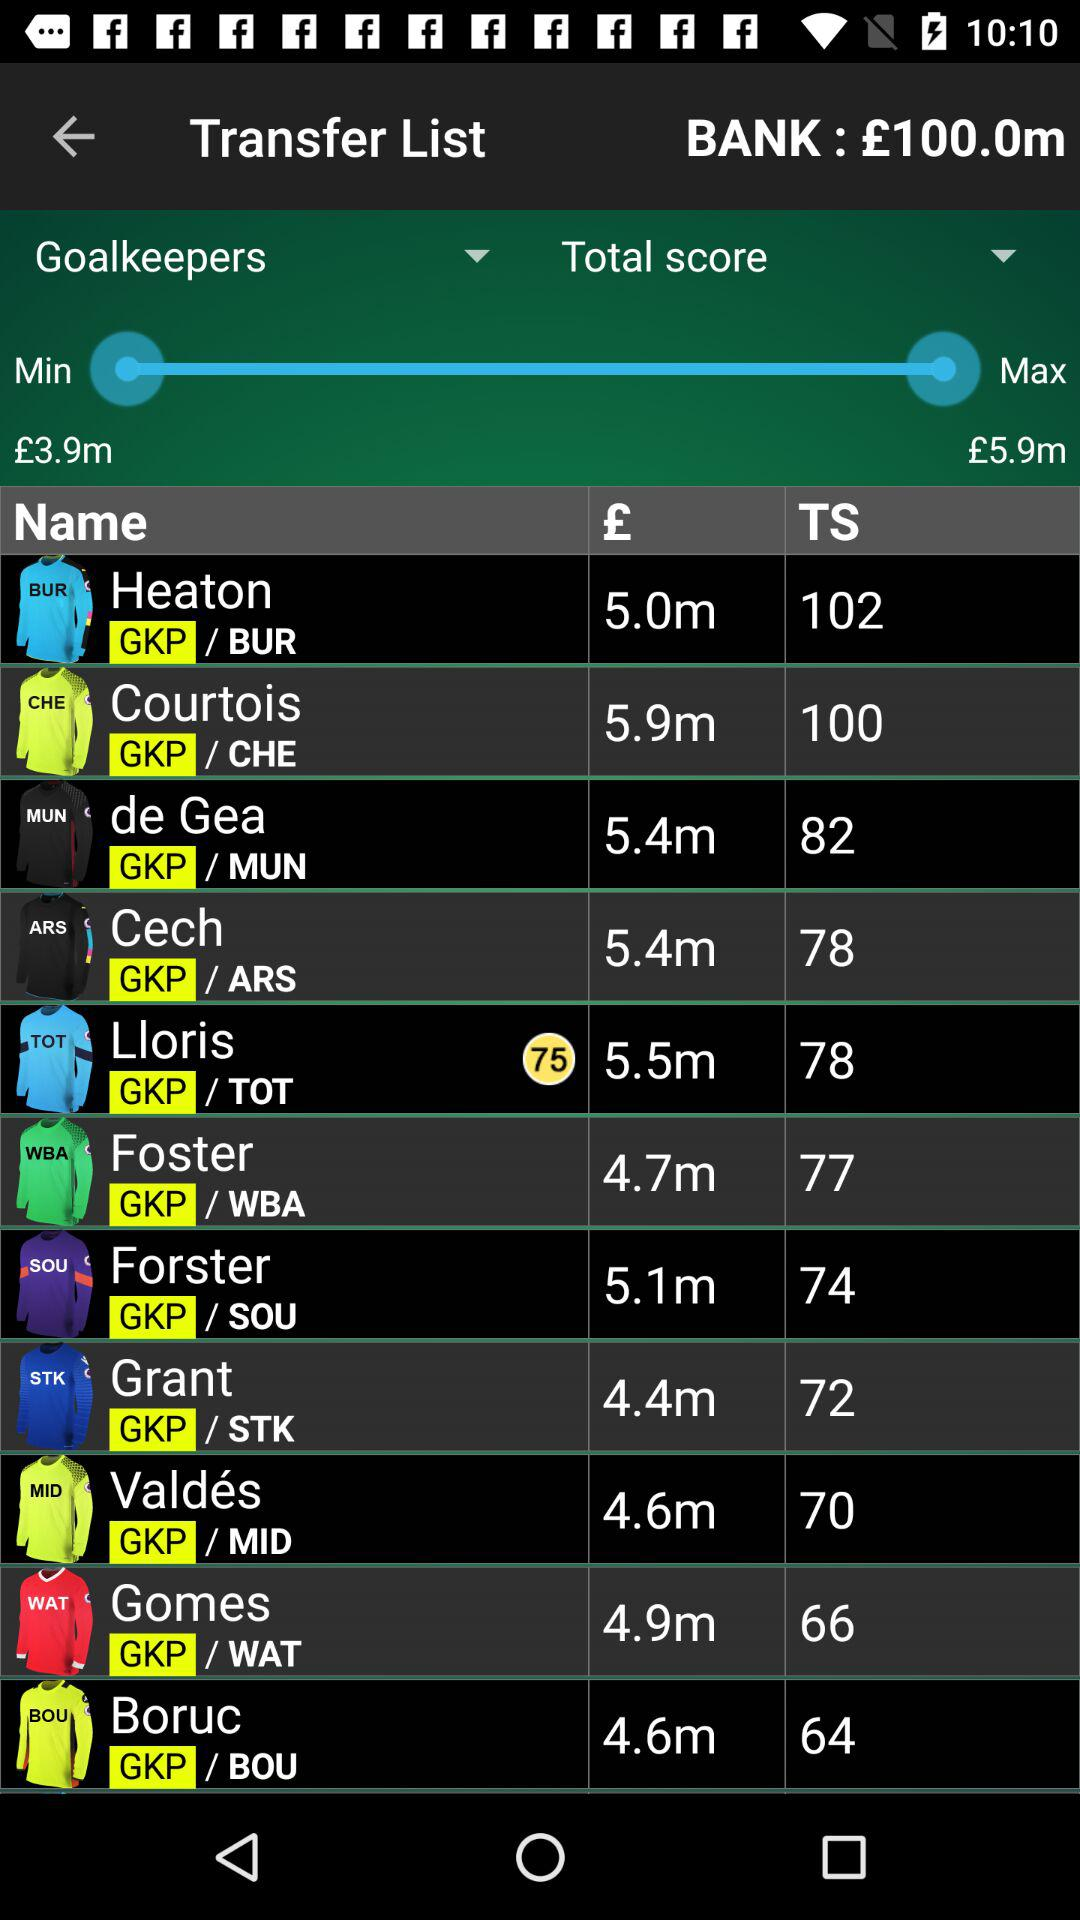Foster belongs to which club? Foster belongs to "WBA" club. 